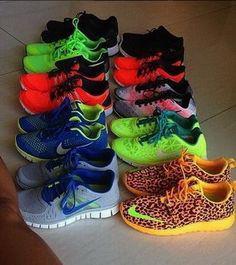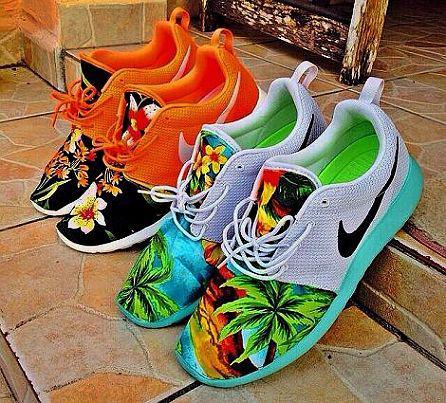The first image is the image on the left, the second image is the image on the right. Assess this claim about the two images: "In the image on the left, a red and yellow shoe is sitting on the right side of the row.". Correct or not? Answer yes or no. No. The first image is the image on the left, the second image is the image on the right. Examine the images to the left and right. Is the description "The image on the right in the pair has fewer than five sneakers." accurate? Answer yes or no. Yes. 